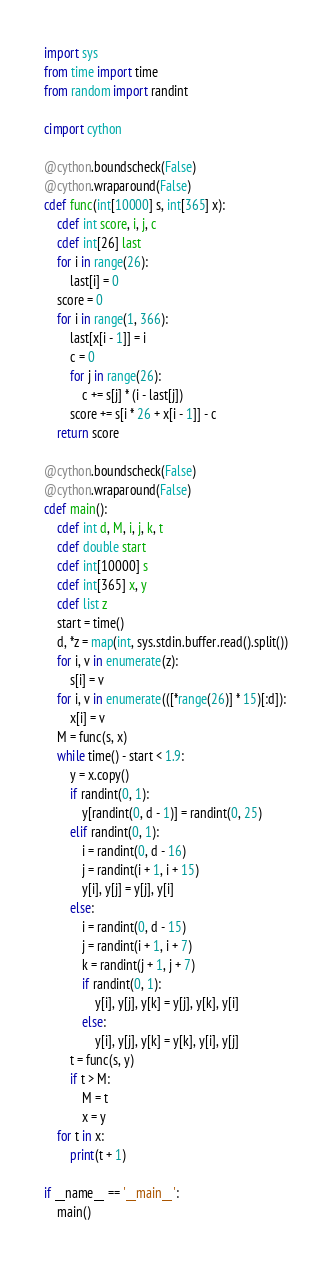<code> <loc_0><loc_0><loc_500><loc_500><_Cython_>import sys
from time import time
from random import randint

cimport cython
 
@cython.boundscheck(False)
@cython.wraparound(False)
cdef func(int[10000] s, int[365] x):
    cdef int score, i, j, c
    cdef int[26] last
    for i in range(26):
        last[i] = 0
    score = 0
    for i in range(1, 366):
        last[x[i - 1]] = i
        c = 0
        for j in range(26):
            c += s[j] * (i - last[j])
        score += s[i * 26 + x[i - 1]] - c
    return score

@cython.boundscheck(False)
@cython.wraparound(False)
cdef main():
    cdef int d, M, i, j, k, t
    cdef double start
    cdef int[10000] s
    cdef int[365] x, y
    cdef list z
    start = time()
    d, *z = map(int, sys.stdin.buffer.read().split())
    for i, v in enumerate(z):
        s[i] = v
    for i, v in enumerate(([*range(26)] * 15)[:d]):
        x[i] = v
    M = func(s, x)
    while time() - start < 1.9:
        y = x.copy()
        if randint(0, 1):
            y[randint(0, d - 1)] = randint(0, 25)
        elif randint(0, 1):
            i = randint(0, d - 16)
            j = randint(i + 1, i + 15)
            y[i], y[j] = y[j], y[i]
        else:
            i = randint(0, d - 15)
            j = randint(i + 1, i + 7)
            k = randint(j + 1, j + 7)
            if randint(0, 1):
                y[i], y[j], y[k] = y[j], y[k], y[i]
            else:
                y[i], y[j], y[k] = y[k], y[i], y[j]
        t = func(s, y)
        if t > M:
            M = t
            x = y
    for t in x:
        print(t + 1)

if __name__ == '__main__':
    main()</code> 